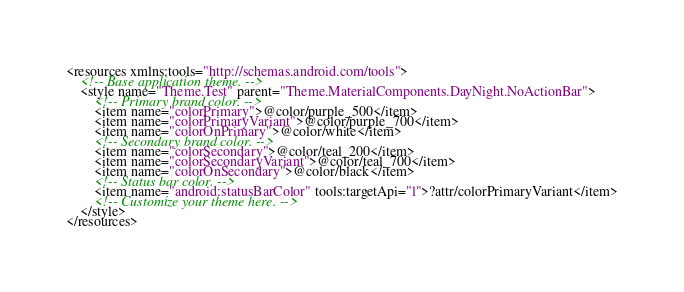Convert code to text. <code><loc_0><loc_0><loc_500><loc_500><_XML_><resources xmlns:tools="http://schemas.android.com/tools">
    <!-- Base application theme. -->
    <style name="Theme.Test" parent="Theme.MaterialComponents.DayNight.NoActionBar">
        <!-- Primary brand color. -->
        <item name="colorPrimary">@color/purple_500</item>
        <item name="colorPrimaryVariant">@color/purple_700</item>
        <item name="colorOnPrimary">@color/white</item>
        <!-- Secondary brand color. -->
        <item name="colorSecondary">@color/teal_200</item>
        <item name="colorSecondaryVariant">@color/teal_700</item>
        <item name="colorOnSecondary">@color/black</item>
        <!-- Status bar color. -->
        <item name="android:statusBarColor" tools:targetApi="l">?attr/colorPrimaryVariant</item>
        <!-- Customize your theme here. -->
    </style>
</resources></code> 